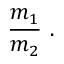Convert formula to latex. <formula><loc_0><loc_0><loc_500><loc_500>{ \frac { m _ { 1 } } { m _ { 2 } } } \ .</formula> 